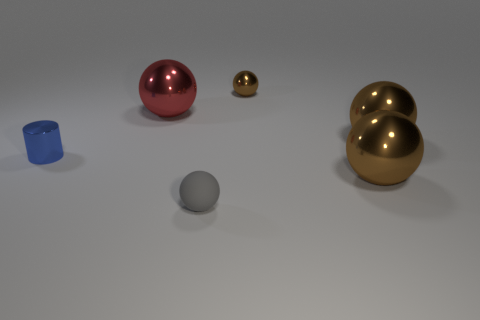Subtract all brown balls. How many were subtracted if there are1brown balls left? 2 Subtract all green cylinders. How many brown balls are left? 3 Subtract all gray balls. How many balls are left? 4 Subtract all tiny metallic balls. How many balls are left? 4 Subtract all cyan spheres. Subtract all green cubes. How many spheres are left? 5 Add 1 gray rubber cylinders. How many objects exist? 7 Subtract all cylinders. How many objects are left? 5 Add 2 big red metallic balls. How many big red metallic balls are left? 3 Add 6 metallic balls. How many metallic balls exist? 10 Subtract 1 red balls. How many objects are left? 5 